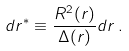<formula> <loc_0><loc_0><loc_500><loc_500>d r ^ { * } \equiv \frac { R ^ { 2 } ( r ) } { \Delta ( r ) } d r \, .</formula> 